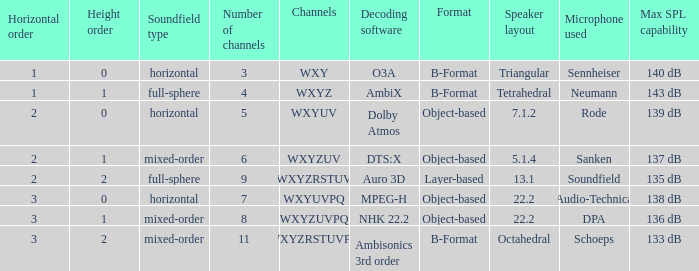If the channels is wxyzrstuvpq, what is the horizontal order? 3.0. 